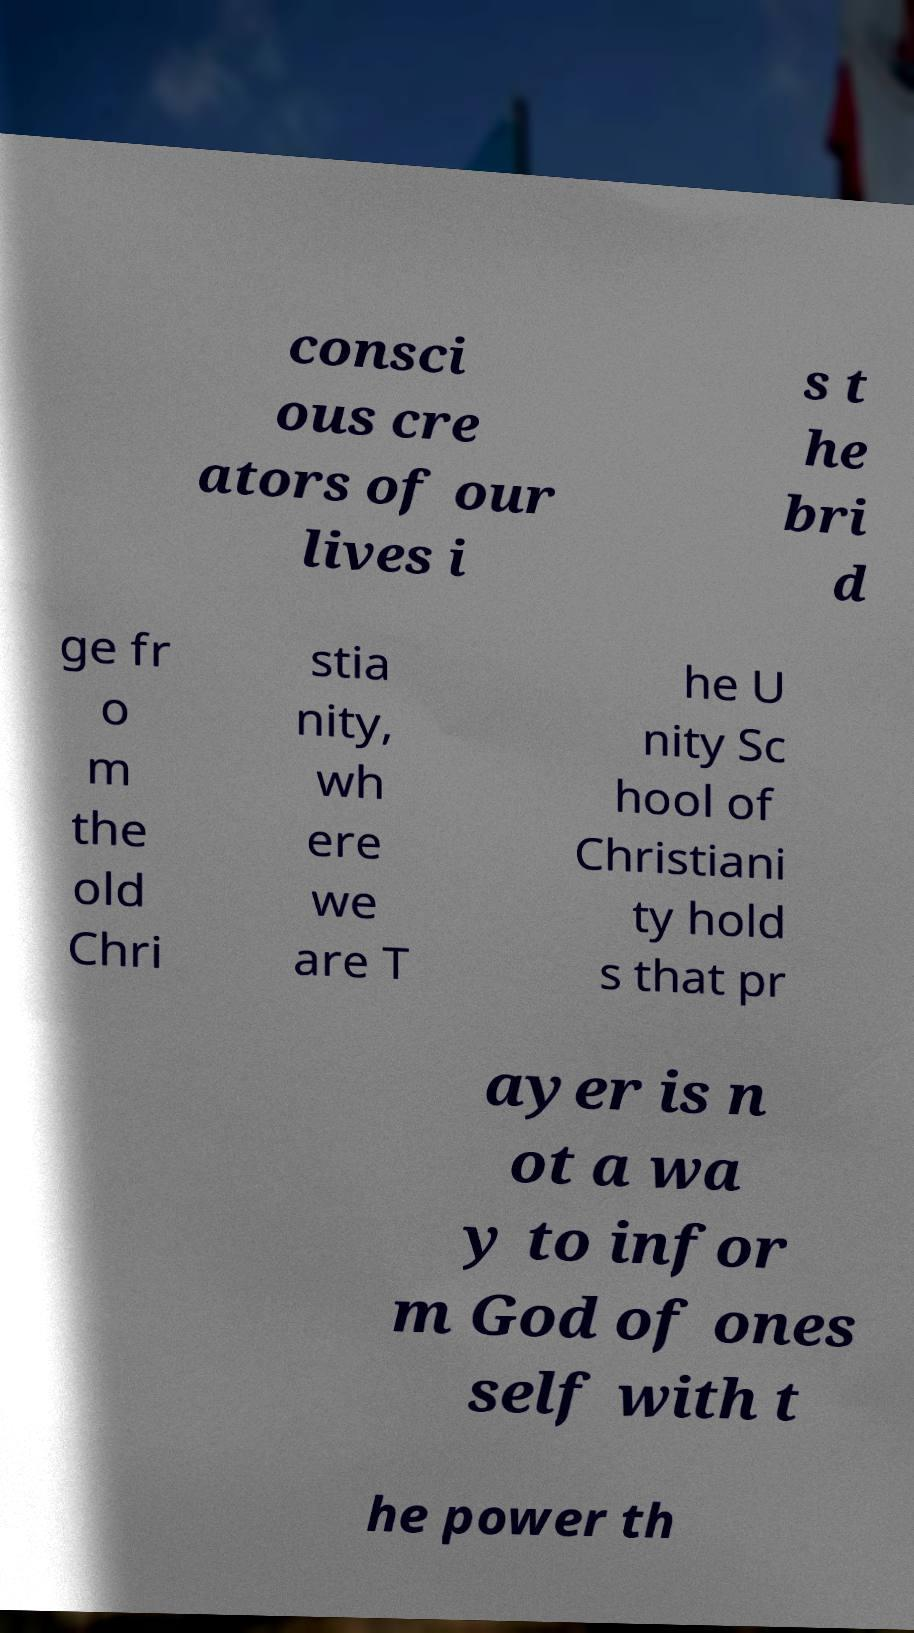Can you read and provide the text displayed in the image?This photo seems to have some interesting text. Can you extract and type it out for me? consci ous cre ators of our lives i s t he bri d ge fr o m the old Chri stia nity, wh ere we are T he U nity Sc hool of Christiani ty hold s that pr ayer is n ot a wa y to infor m God of ones self with t he power th 